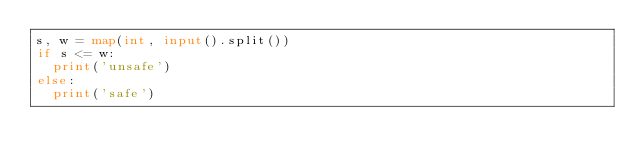Convert code to text. <code><loc_0><loc_0><loc_500><loc_500><_Python_>s, w = map(int, input().split())
if s <= w:
  print('unsafe')
else:
  print('safe')</code> 